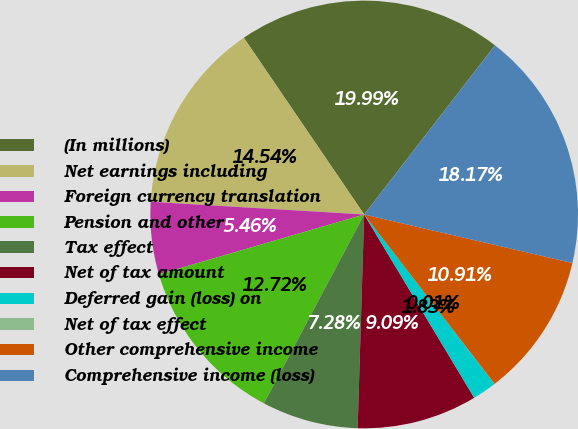<chart> <loc_0><loc_0><loc_500><loc_500><pie_chart><fcel>(In millions)<fcel>Net earnings including<fcel>Foreign currency translation<fcel>Pension and other<fcel>Tax effect<fcel>Net of tax amount<fcel>Deferred gain (loss) on<fcel>Net of tax effect<fcel>Other comprehensive income<fcel>Comprehensive income (loss)<nl><fcel>19.99%<fcel>14.54%<fcel>5.46%<fcel>12.72%<fcel>7.28%<fcel>9.09%<fcel>1.83%<fcel>0.01%<fcel>10.91%<fcel>18.17%<nl></chart> 